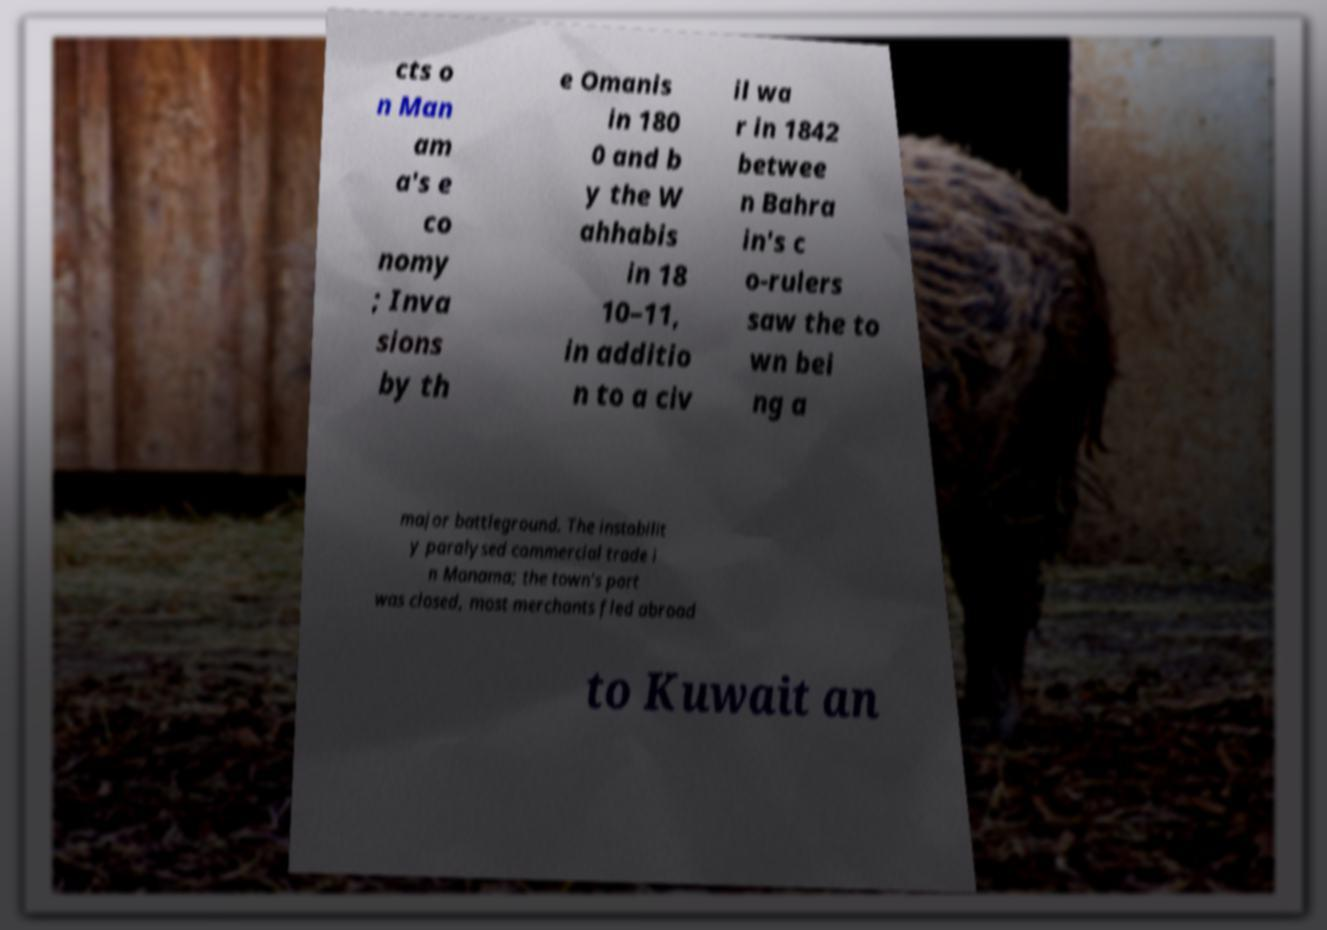Could you assist in decoding the text presented in this image and type it out clearly? cts o n Man am a's e co nomy ; Inva sions by th e Omanis in 180 0 and b y the W ahhabis in 18 10–11, in additio n to a civ il wa r in 1842 betwee n Bahra in's c o-rulers saw the to wn bei ng a major battleground. The instabilit y paralysed commercial trade i n Manama; the town's port was closed, most merchants fled abroad to Kuwait an 